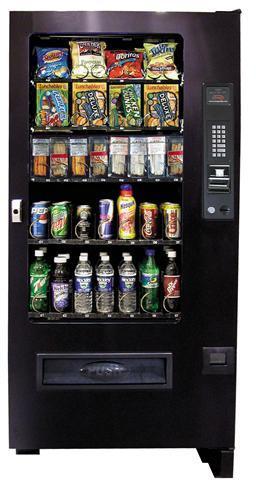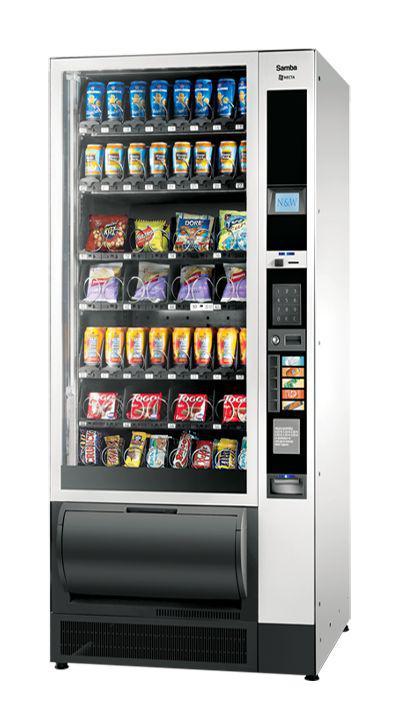The first image is the image on the left, the second image is the image on the right. Given the left and right images, does the statement "At least one vending machine pictured is black with a footed base." hold true? Answer yes or no. Yes. The first image is the image on the left, the second image is the image on the right. For the images displayed, is the sentence "The right image contains exactly one silver vending machine." factually correct? Answer yes or no. Yes. 